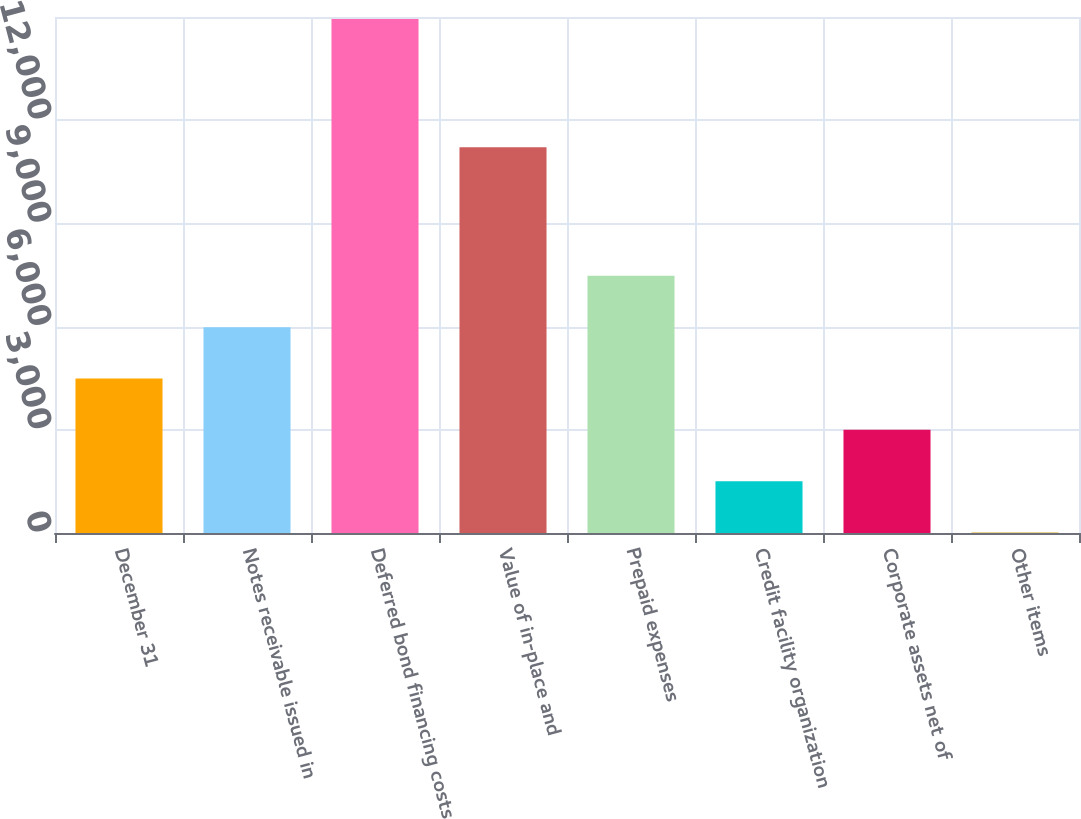<chart> <loc_0><loc_0><loc_500><loc_500><bar_chart><fcel>December 31<fcel>Notes receivable issued in<fcel>Deferred bond financing costs<fcel>Value of in-place and<fcel>Prepaid expenses<fcel>Credit facility organization<fcel>Corporate assets net of<fcel>Other items<nl><fcel>4491.1<fcel>5983.8<fcel>14940<fcel>11211<fcel>7476.5<fcel>1505.7<fcel>2998.4<fcel>13<nl></chart> 